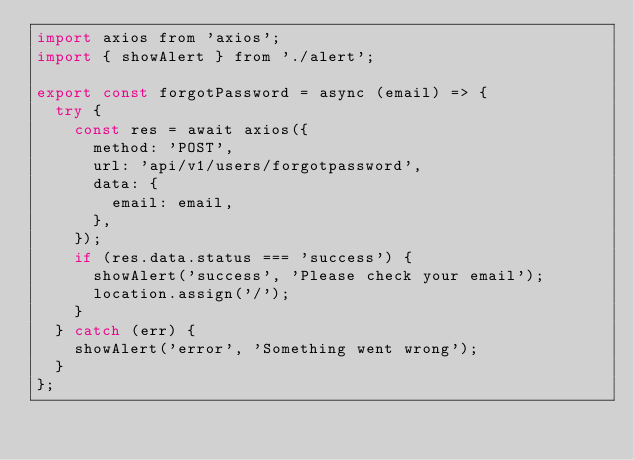<code> <loc_0><loc_0><loc_500><loc_500><_JavaScript_>import axios from 'axios';
import { showAlert } from './alert';

export const forgotPassword = async (email) => {
  try {
    const res = await axios({
      method: 'POST',
      url: 'api/v1/users/forgotpassword',
      data: {
        email: email,
      },
    });
    if (res.data.status === 'success') {
      showAlert('success', 'Please check your email');
      location.assign('/');
    }
  } catch (err) {
    showAlert('error', 'Something went wrong');
  }
};
</code> 